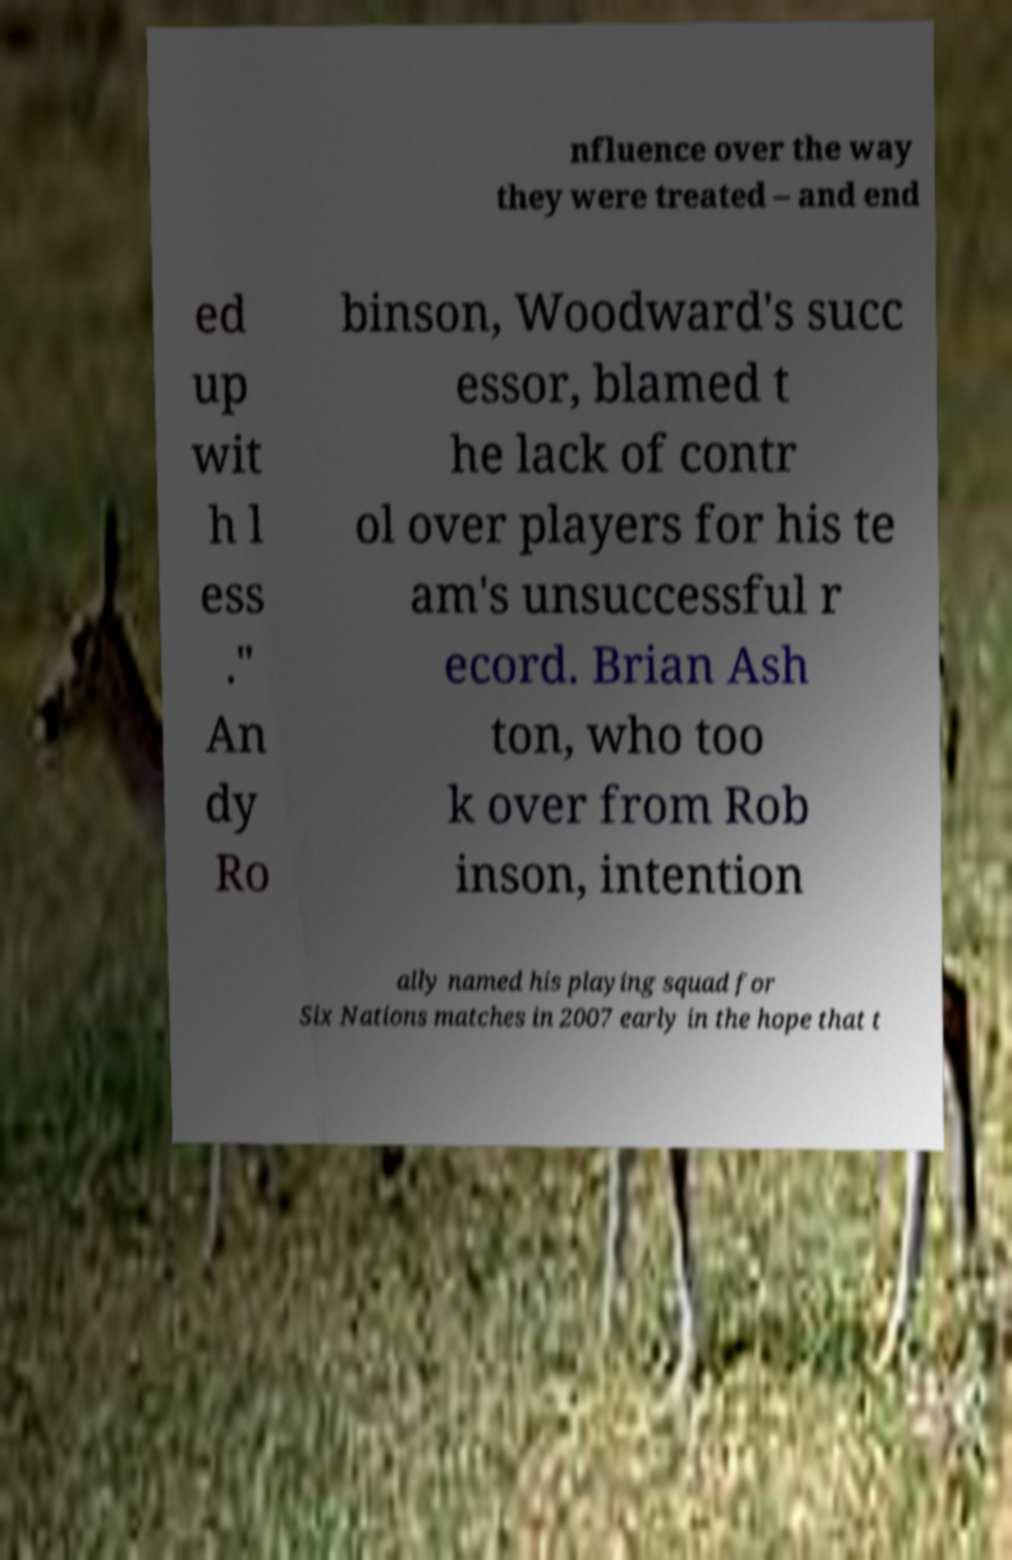I need the written content from this picture converted into text. Can you do that? nfluence over the way they were treated – and end ed up wit h l ess ." An dy Ro binson, Woodward's succ essor, blamed t he lack of contr ol over players for his te am's unsuccessful r ecord. Brian Ash ton, who too k over from Rob inson, intention ally named his playing squad for Six Nations matches in 2007 early in the hope that t 